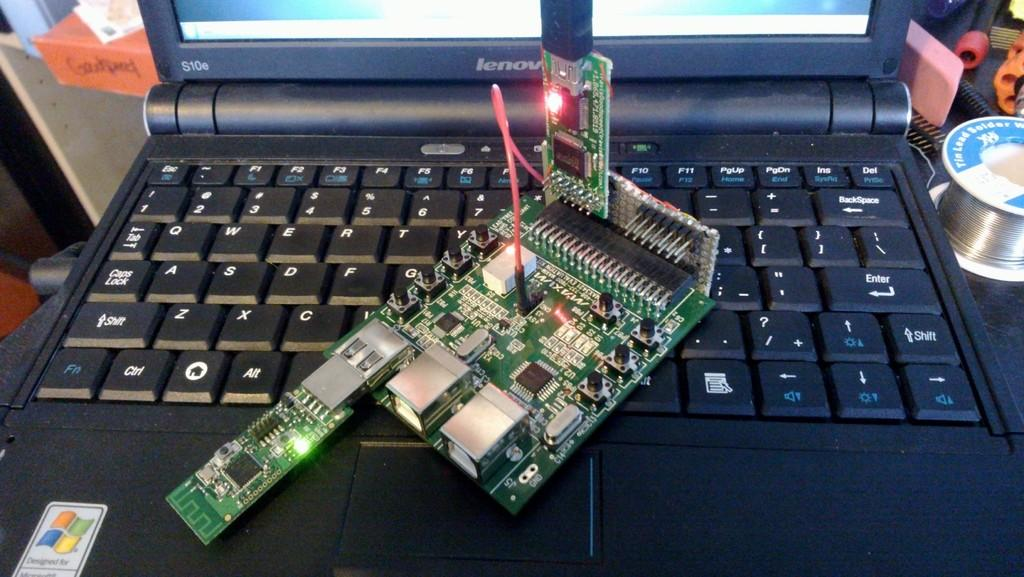What is the main object in the image? There is a laptop keyboard in the image. What is located above the laptop keyboard? There is a circuit above the laptop keyboard. What else can be seen beside the laptop in the image? There are objects beside the laptop. What operating system is suggested by the logo in the image? The Windows logo is visible in the image, suggesting that the laptop runs on the Windows operating system. How many cows are visible in the image? There are no cows present in the image. What type of calendar is displayed on the laptop screen? There is no calendar visible in the image, as it focuses on the laptop keyboard and circuit. 